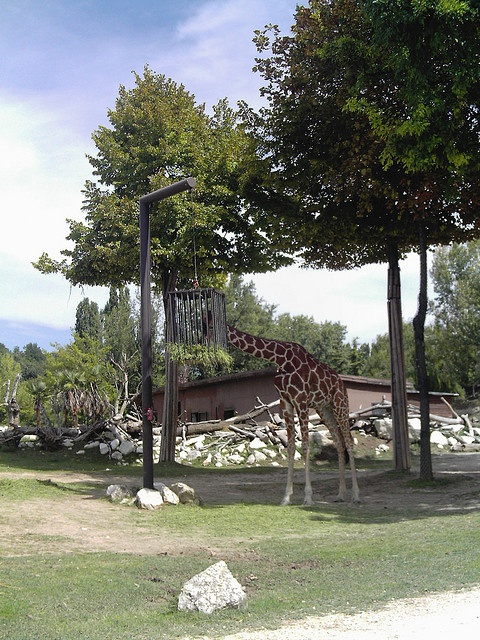Describe the objects in this image and their specific colors. I can see a giraffe in lavender, gray, black, and maroon tones in this image. 